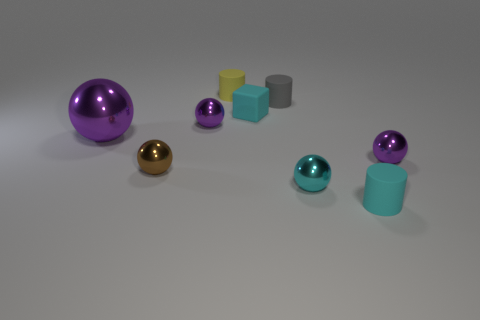There is a gray thing that is the same size as the matte block; what is its shape?
Ensure brevity in your answer.  Cylinder. What shape is the metallic thing that is both to the right of the brown thing and left of the block?
Offer a very short reply. Sphere. What material is the small brown object?
Offer a very short reply. Metal. What number of spheres are big metallic objects or gray rubber things?
Provide a short and direct response. 1. Is the material of the small gray object the same as the tiny yellow thing?
Keep it short and to the point. Yes. There is a brown thing that is the same shape as the cyan shiny thing; what is its size?
Your answer should be compact. Small. What is the thing that is both on the right side of the gray object and behind the tiny cyan metallic ball made of?
Your response must be concise. Metal. Is the number of small brown metallic objects that are behind the brown metallic object the same as the number of yellow balls?
Keep it short and to the point. Yes. How many things are tiny objects right of the yellow thing or red balls?
Give a very brief answer. 5. Does the metal sphere that is behind the big purple thing have the same color as the big object?
Your answer should be compact. Yes. 